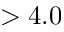Convert formula to latex. <formula><loc_0><loc_0><loc_500><loc_500>> 4 . 0</formula> 